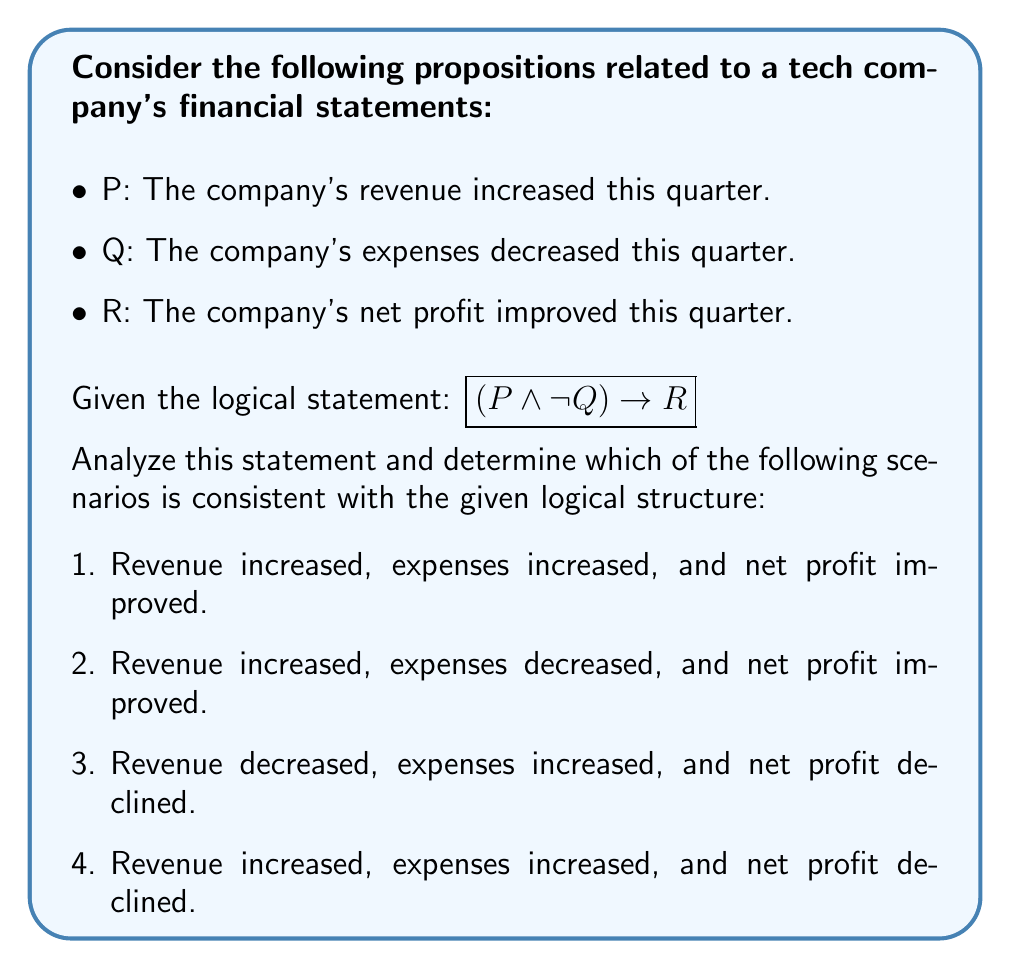Show me your answer to this math problem. Let's analyze this step-by-step using propositional logic:

1) The given logical statement is: $$(P \land \neg Q) \rightarrow R$$

2) This can be interpreted as: "If revenue increased AND expenses did not decrease, then net profit improved."

3) Let's break down each scenario:

   Scenario 1: P is true, Q is false (since expenses increased), R is true
   - This satisfies $(P \land \neg Q)$, and R is true, so it's consistent.

   Scenario 2: P is true, Q is true, R is true
   - This doesn't satisfy $(P \land \neg Q)$, so we can't conclude about R.

   Scenario 3: P is false, Q is false, R is false
   - The antecedent $(P \land \neg Q)$ is false, so the implication is true regardless of R.

   Scenario 4: P is true, Q is false (since expenses increased), R is false
   - This satisfies $(P \land \neg Q)$, but R is false, contradicting the implication.

4) The only scenario that is fully consistent with the given logical structure is Scenario 1.

5) In this scenario, even though both revenue and expenses increased, the statement holds true because net profit still improved. This could happen if the increase in revenue outpaced the increase in expenses.
Answer: Scenario 1 